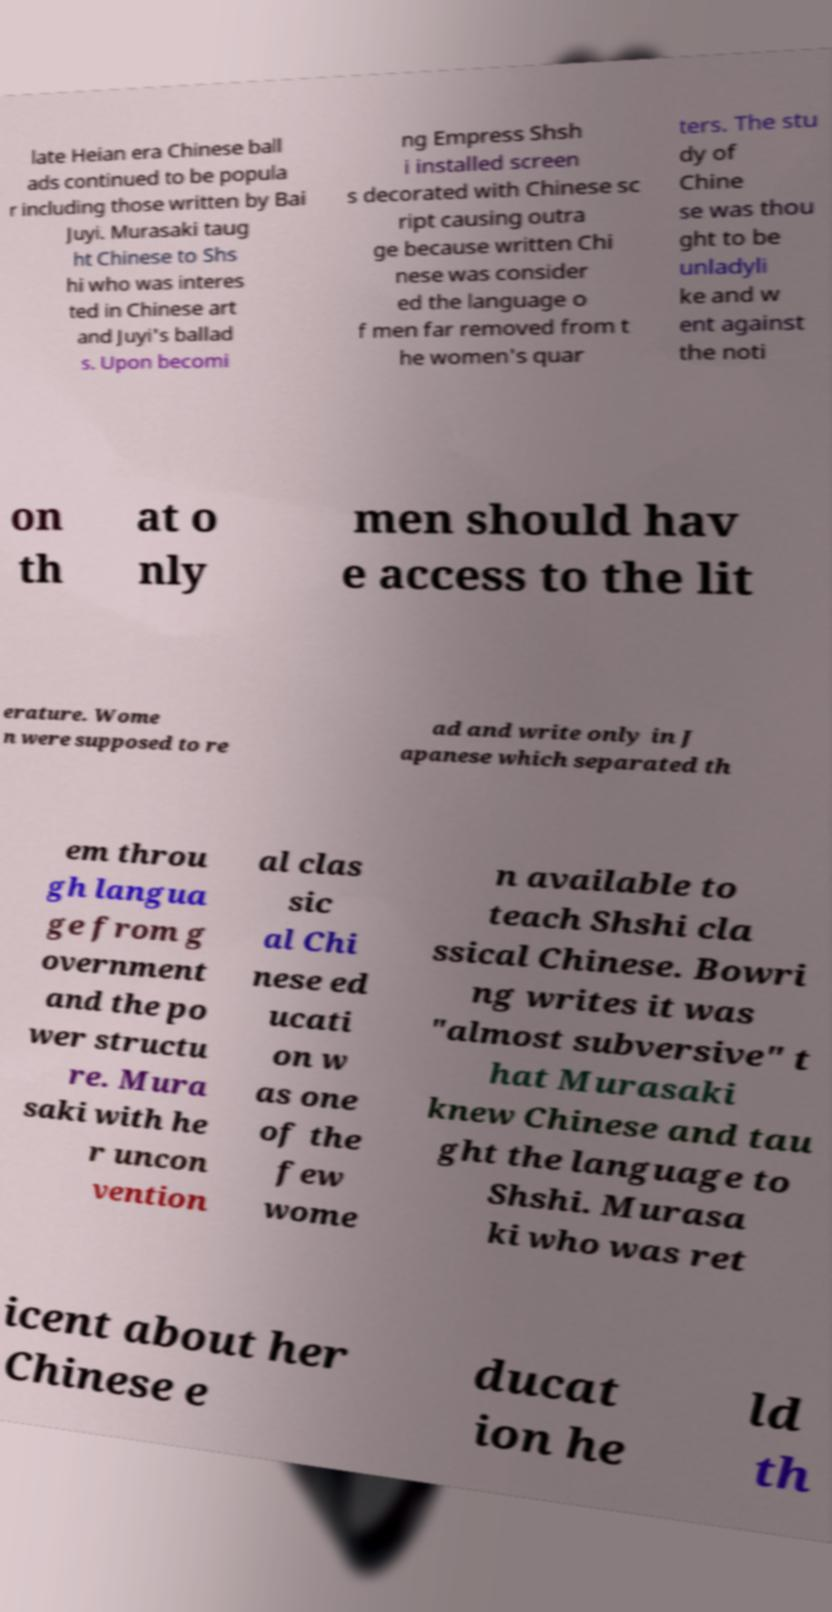For documentation purposes, I need the text within this image transcribed. Could you provide that? late Heian era Chinese ball ads continued to be popula r including those written by Bai Juyi. Murasaki taug ht Chinese to Shs hi who was interes ted in Chinese art and Juyi's ballad s. Upon becomi ng Empress Shsh i installed screen s decorated with Chinese sc ript causing outra ge because written Chi nese was consider ed the language o f men far removed from t he women's quar ters. The stu dy of Chine se was thou ght to be unladyli ke and w ent against the noti on th at o nly men should hav e access to the lit erature. Wome n were supposed to re ad and write only in J apanese which separated th em throu gh langua ge from g overnment and the po wer structu re. Mura saki with he r uncon vention al clas sic al Chi nese ed ucati on w as one of the few wome n available to teach Shshi cla ssical Chinese. Bowri ng writes it was "almost subversive" t hat Murasaki knew Chinese and tau ght the language to Shshi. Murasa ki who was ret icent about her Chinese e ducat ion he ld th 